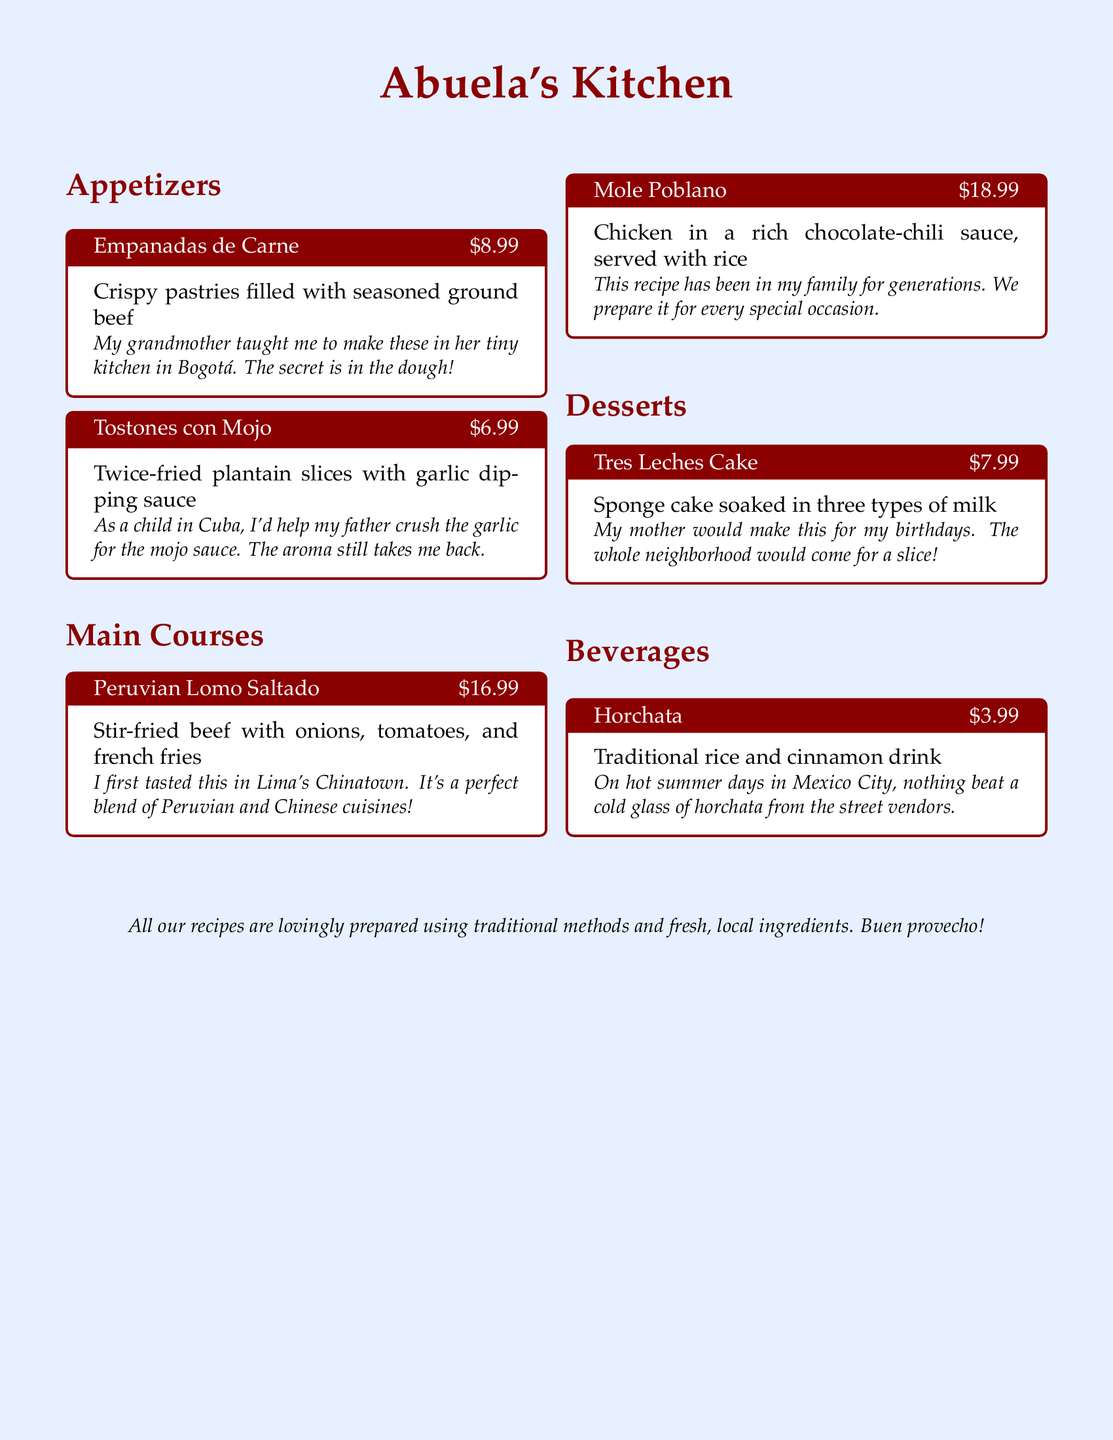What is the price of Empanadas de Carne? The price for Empanadas de Carne, as listed on the menu, is $8.99.
Answer: $8.99 What is the primary ingredient in Tostones con Mojo? Tostones con Mojo features twice-fried plantain slices as its main ingredient.
Answer: Plantain What city is associated with the origin of Lomo Saltado? The document states that Lomo Saltado was first tasted in Lima, Peru.
Answer: Lima What is the chocolate-chili sauce made for? The Mole Poblano dish is typically prepared for special occasions according to the document.
Answer: Special occasions Which dessert is made by soaking sponge cake in three types of milk? The Tres Leches Cake is the dessert that is prepared by soaking sponge cake in three types of milk.
Answer: Tres Leches Cake What summer drink is mentioned in the menu? The menu mentions horchata as the traditional summer drink.
Answer: Horchata How many appetizers are listed in the menu? The document lists two appetizers: Empanadas de Carne and Tostones con Mojo.
Answer: Two What special method is used in preparing the recipes? The recipes are prepared using traditional methods as stated in the menu's closing note.
Answer: Traditional methods What ingredient gives horchata its flavor? The key flavoring ingredient in horchata, as mentioned, is cinnamon.
Answer: Cinnamon What type of cuisine does Lomo Saltado represent? Lomo Saltado is a blend of Peruvian and Chinese cuisines.
Answer: Peruvian and Chinese cuisines 